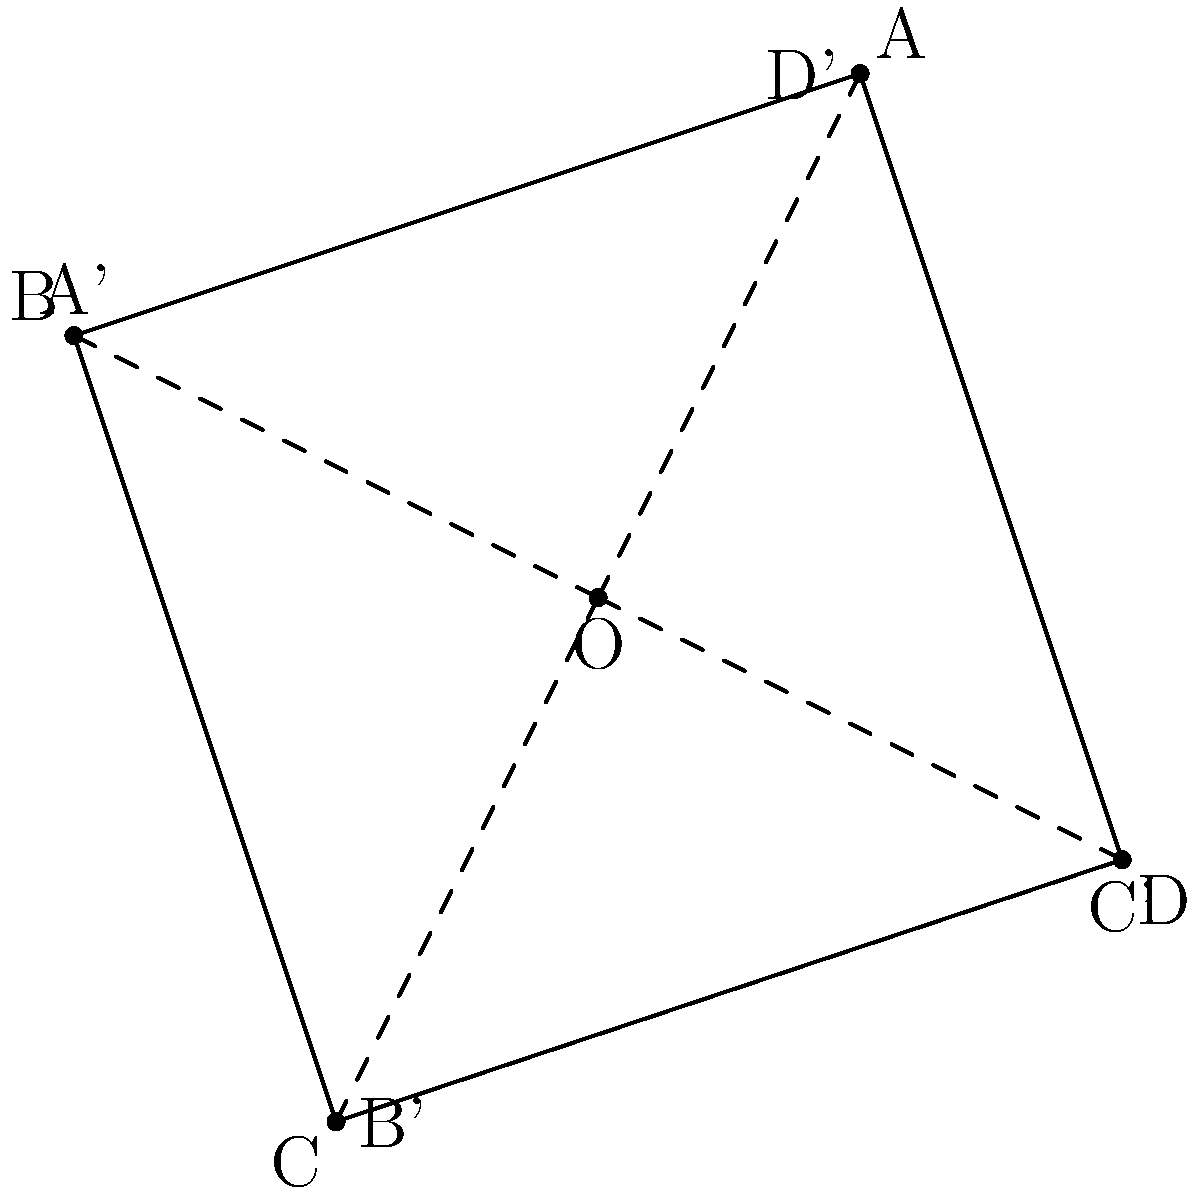In the map of Greylock from "The Republic of Sarah", the town is represented by the quadrilateral ABCD. If the map is rotated 90° clockwise around point O, what will be the new coordinates of point A, originally at (1, 2)? To find the new coordinates of point A after a 90° clockwise rotation around point O, we can follow these steps:

1. Recall the rotation formula for a 90° clockwise rotation:
   $$(x, y) \rightarrow (y, -x)$$

2. The original coordinates of point A are (1, 2).

3. Apply the rotation formula:
   $x' = y = 2$
   $y' = -x = -1$

4. Therefore, the new coordinates of A after rotation are (2, -1).

This rotation represents a different perspective of Greylock's map, which could be useful for Sarah and the town's residents when considering various aspects of their independence and governance.
Answer: (2, -1) 